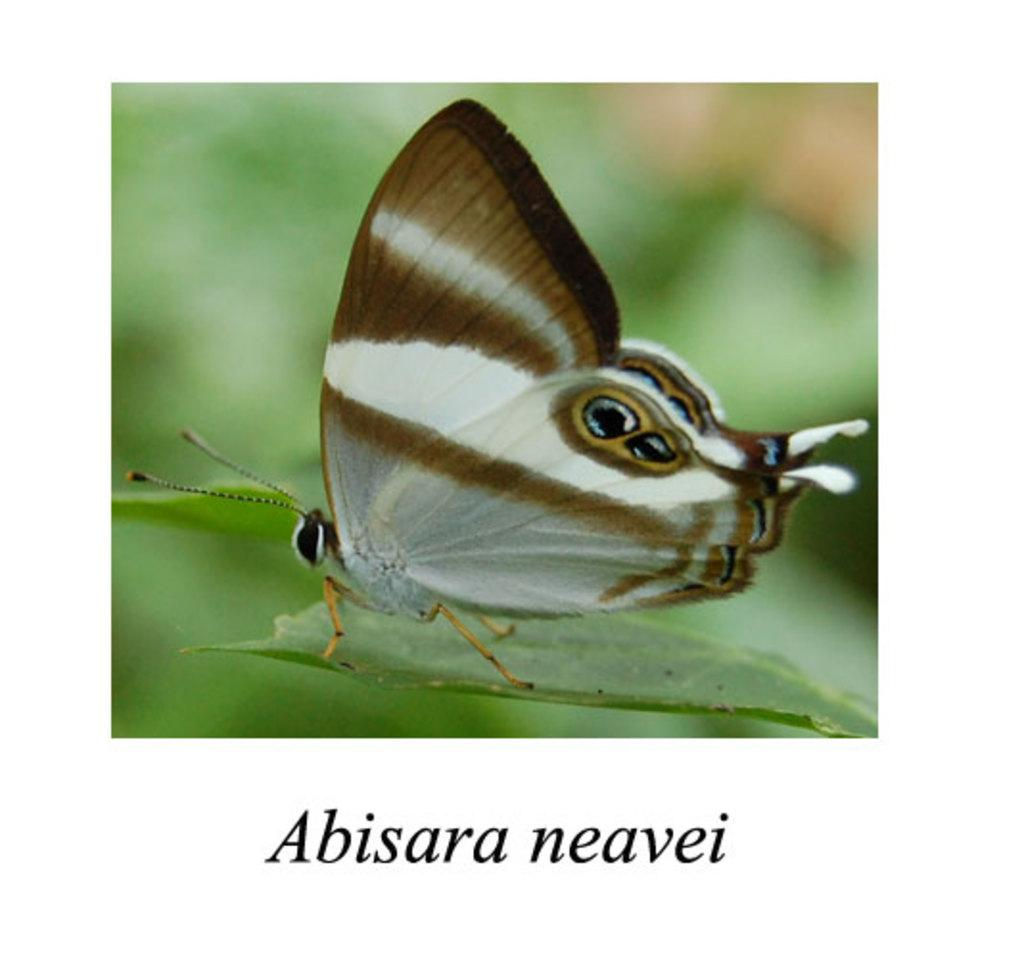What is the main subject of the image? There is a butterfly on a leaf in the image. Can you describe the background of the image? The background of the image is blurred. Is there any additional information or markings on the image? Yes, there is a watermark at the bottom of the image. What type of trouble is the parent experiencing in the image? There is no parent or any indication of trouble present in the image; it features a butterfly on a leaf with a blurred background and a watermark. 